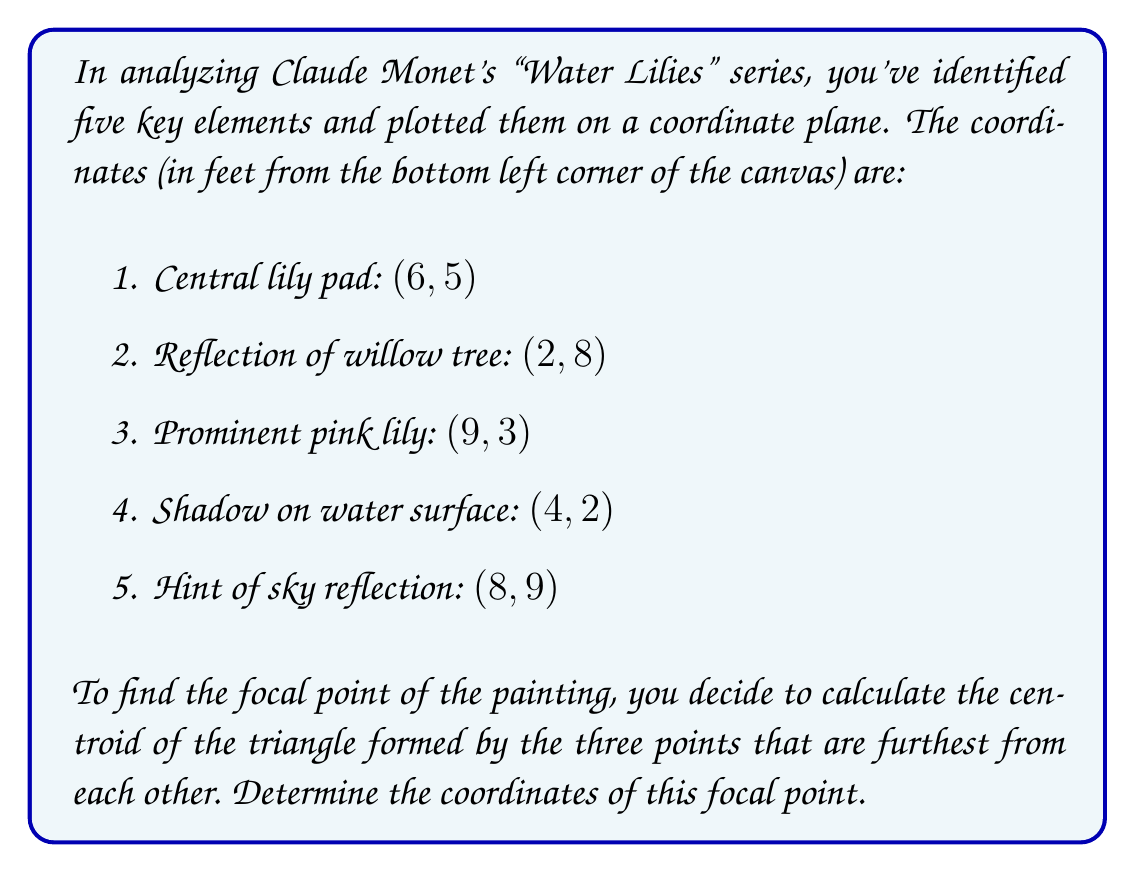Can you answer this question? To solve this problem, we'll follow these steps:

1. Identify the three points furthest from each other:
   We can visually determine that the three points furthest apart are:
   A(2, 8), B(9, 3), and C(8, 9)

2. Calculate the centroid of the triangle formed by these points:
   The centroid formula for a triangle with vertices $(x_1, y_1)$, $(x_2, y_2)$, and $(x_3, y_3)$ is:

   $$x_{centroid} = \frac{x_1 + x_2 + x_3}{3}$$
   $$y_{centroid} = \frac{y_1 + y_2 + y_3}{3}$$

3. Substitute the coordinates into the formulas:

   $$x_{centroid} = \frac{2 + 9 + 8}{3} = \frac{19}{3} \approx 6.33$$
   $$y_{centroid} = \frac{8 + 3 + 9}{3} = \frac{20}{3} \approx 6.67$$

4. Round the results to two decimal places for a practical focal point on the canvas.

Therefore, the focal point of the painting is approximately (6.33, 6.67) feet from the bottom left corner of the canvas.
Answer: The focal point of the painting is (6.33, 6.67). 